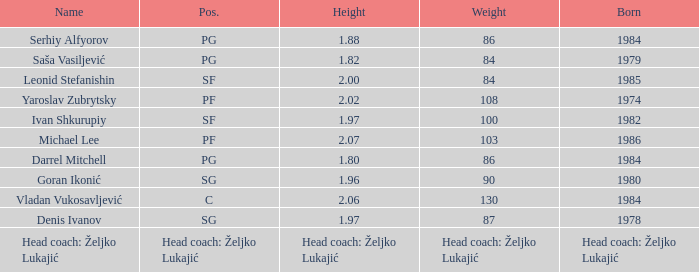What was the measurement of serhiy alfyorov's weight? 86.0. 